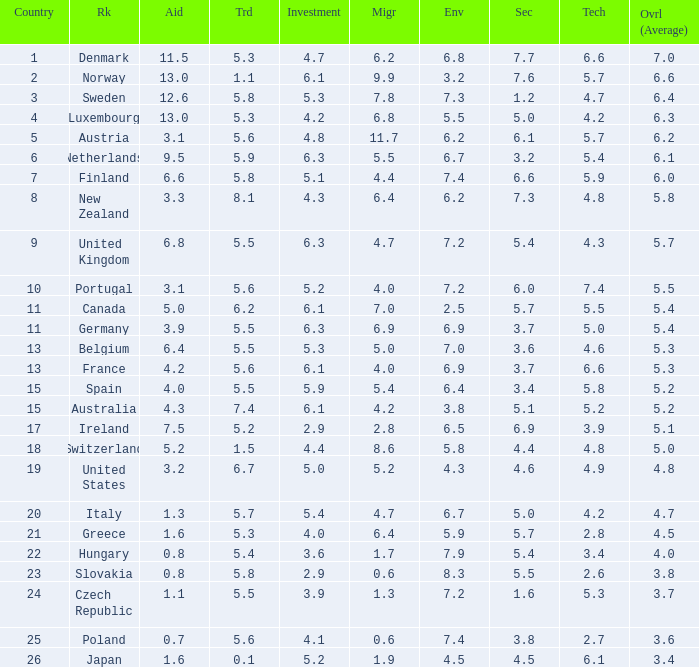What is the environment rating of the country with an overall average rating of 4.7? 6.7. 